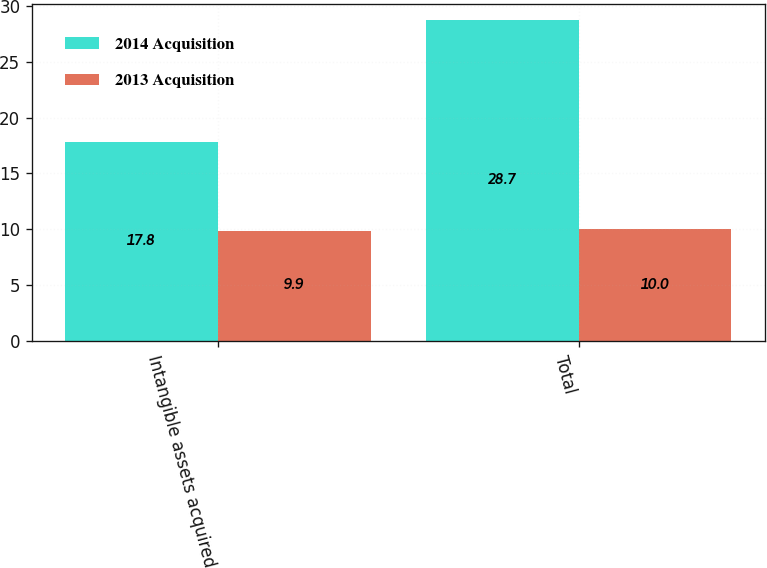Convert chart. <chart><loc_0><loc_0><loc_500><loc_500><stacked_bar_chart><ecel><fcel>Intangible assets acquired<fcel>Total<nl><fcel>2014 Acquisition<fcel>17.8<fcel>28.7<nl><fcel>2013 Acquisition<fcel>9.9<fcel>10<nl></chart> 